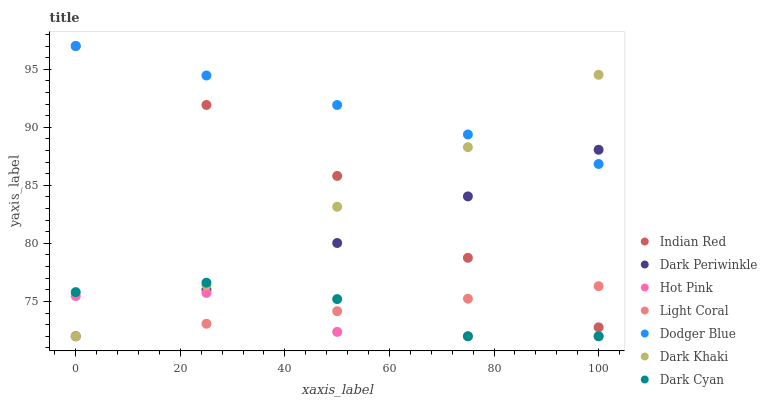Does Hot Pink have the minimum area under the curve?
Answer yes or no. Yes. Does Dodger Blue have the maximum area under the curve?
Answer yes or no. Yes. Does Light Coral have the minimum area under the curve?
Answer yes or no. No. Does Light Coral have the maximum area under the curve?
Answer yes or no. No. Is Dark Periwinkle the smoothest?
Answer yes or no. Yes. Is Dark Cyan the roughest?
Answer yes or no. Yes. Is Hot Pink the smoothest?
Answer yes or no. No. Is Hot Pink the roughest?
Answer yes or no. No. Does Dark Khaki have the lowest value?
Answer yes or no. Yes. Does Dodger Blue have the lowest value?
Answer yes or no. No. Does Indian Red have the highest value?
Answer yes or no. Yes. Does Light Coral have the highest value?
Answer yes or no. No. Is Light Coral less than Dodger Blue?
Answer yes or no. Yes. Is Dodger Blue greater than Hot Pink?
Answer yes or no. Yes. Does Indian Red intersect Light Coral?
Answer yes or no. Yes. Is Indian Red less than Light Coral?
Answer yes or no. No. Is Indian Red greater than Light Coral?
Answer yes or no. No. Does Light Coral intersect Dodger Blue?
Answer yes or no. No. 